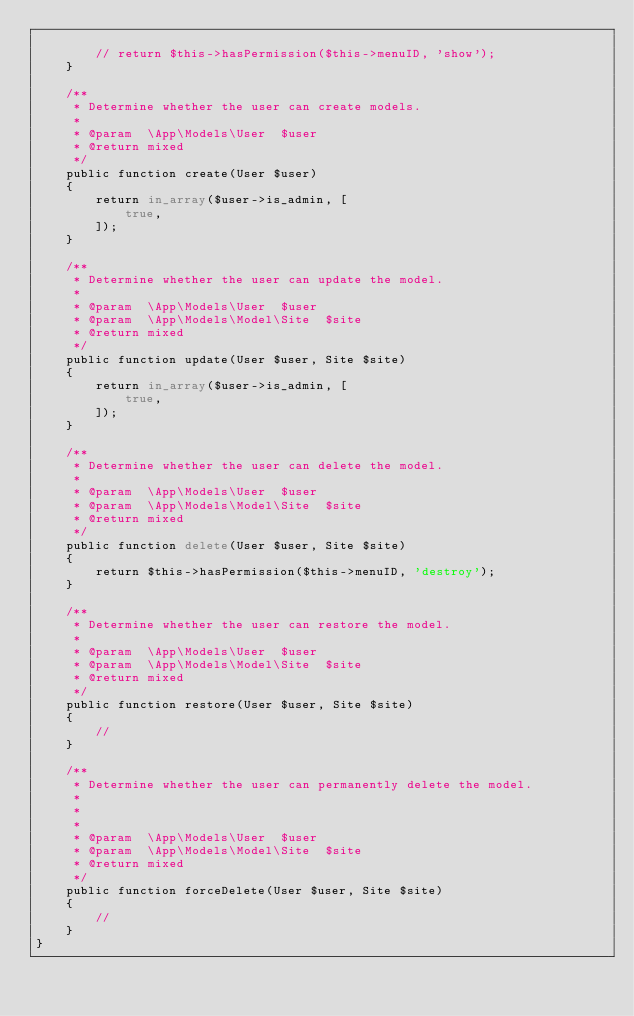Convert code to text. <code><loc_0><loc_0><loc_500><loc_500><_PHP_>
        // return $this->hasPermission($this->menuID, 'show');
    }

    /**
     * Determine whether the user can create models.
     *
     * @param  \App\Models\User  $user
     * @return mixed
     */
    public function create(User $user)
    {
        return in_array($user->is_admin, [
            true,
        ]);
    }

    /**
     * Determine whether the user can update the model.
     *
     * @param  \App\Models\User  $user
     * @param  \App\Models\Model\Site  $site
     * @return mixed
     */
    public function update(User $user, Site $site)
    {
        return in_array($user->is_admin, [
            true,
        ]);
    }

    /**
     * Determine whether the user can delete the model.
     *
     * @param  \App\Models\User  $user
     * @param  \App\Models\Model\Site  $site
     * @return mixed
     */
    public function delete(User $user, Site $site)
    {
        return $this->hasPermission($this->menuID, 'destroy');
    }

    /**
     * Determine whether the user can restore the model.
     *
     * @param  \App\Models\User  $user
     * @param  \App\Models\Model\Site  $site
     * @return mixed
     */
    public function restore(User $user, Site $site)
    {
        //
    }

    /**
     * Determine whether the user can permanently delete the model.
     *
     *
     *
     * @param  \App\Models\User  $user
     * @param  \App\Models\Model\Site  $site
     * @return mixed
     */
    public function forceDelete(User $user, Site $site)
    {
        //
    }
}
</code> 